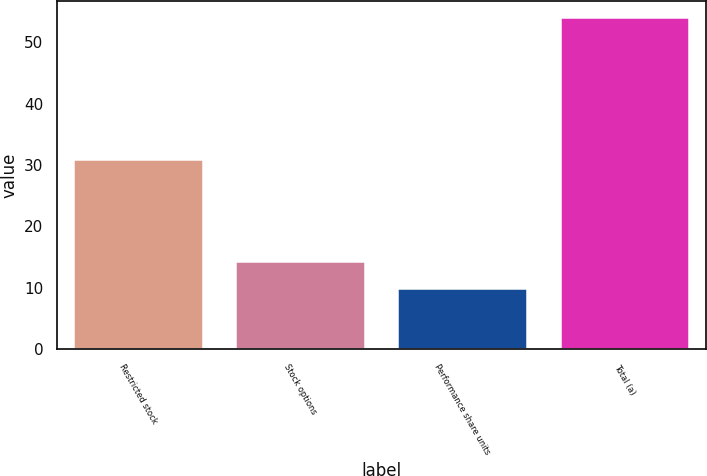Convert chart. <chart><loc_0><loc_0><loc_500><loc_500><bar_chart><fcel>Restricted stock<fcel>Stock options<fcel>Performance share units<fcel>Total (a)<nl><fcel>31<fcel>14.4<fcel>10<fcel>54<nl></chart> 